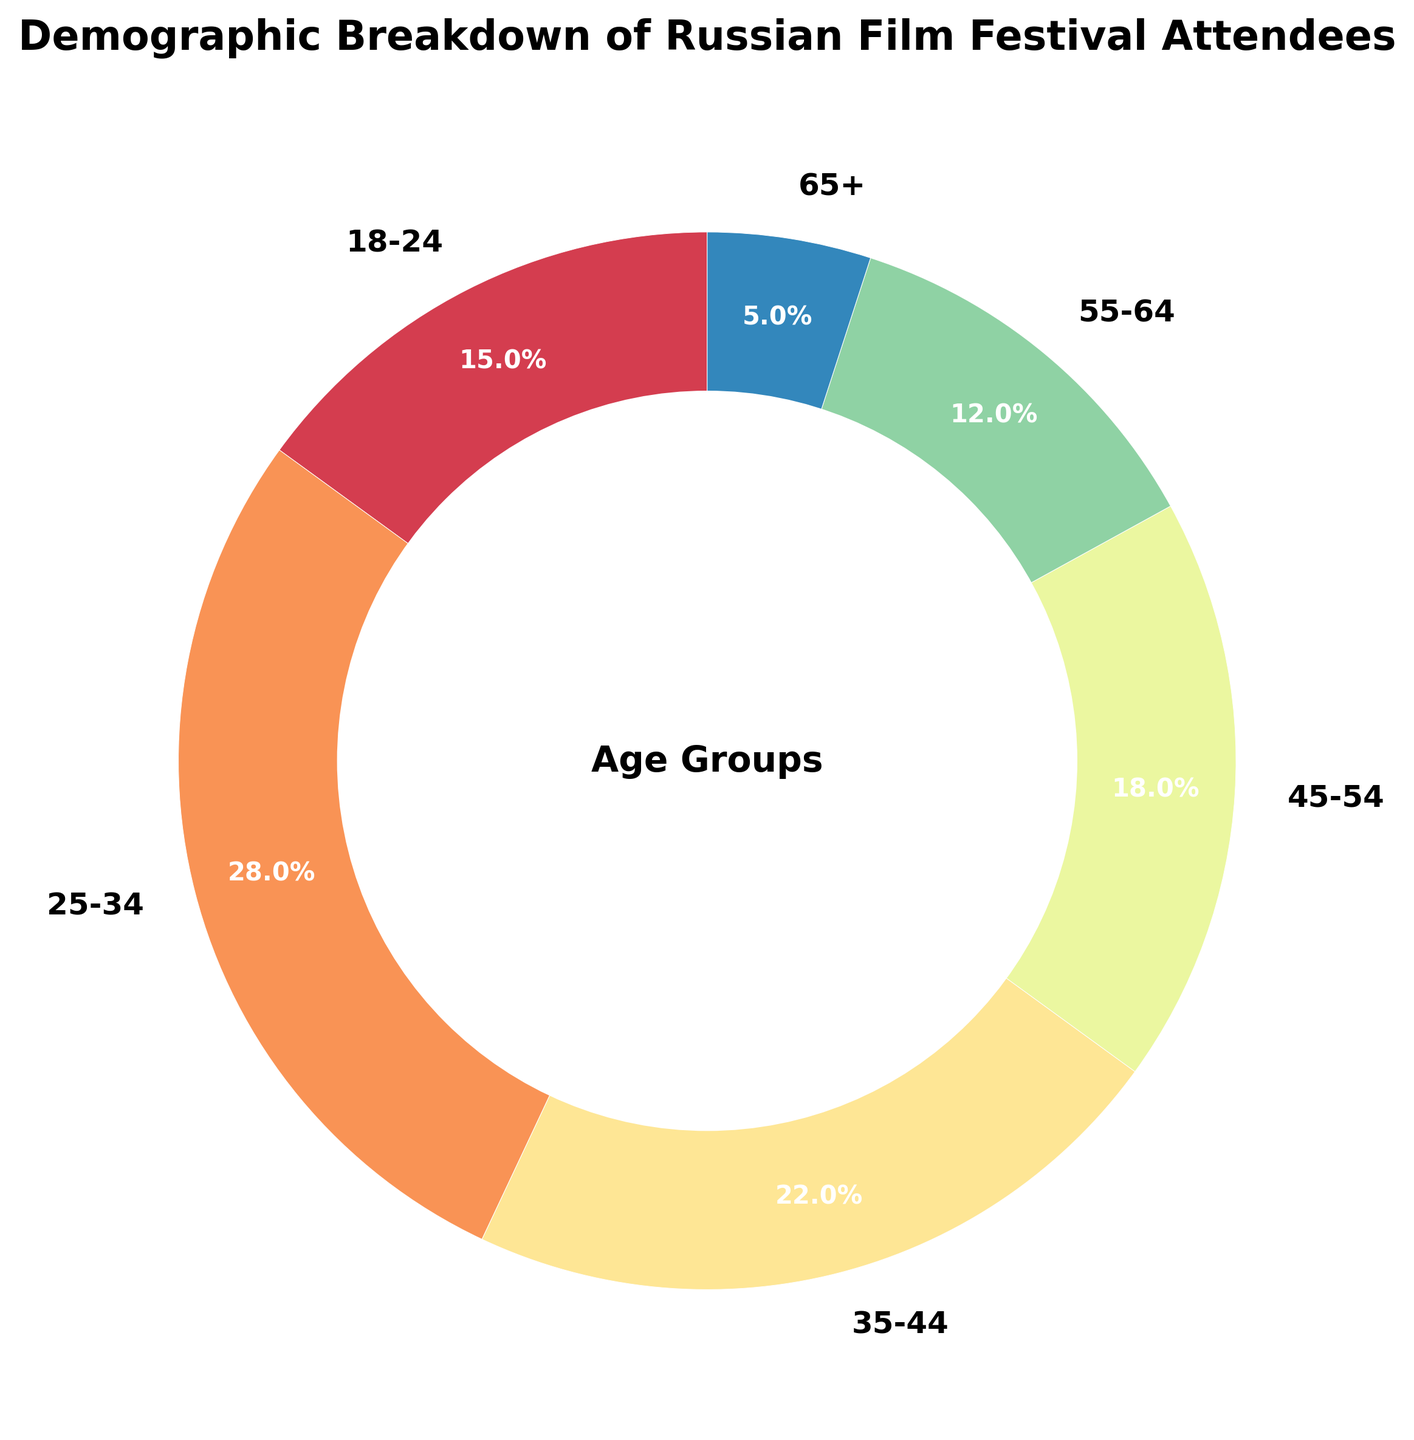What is the most represented age group at the festival? The figure shows that the age group 25-34 has the highest percentage at 28%, making it the most represented group.
Answer: 25-34 Which age group has the smallest percentage of attendees? The figure indicates that the age group 65+ has the smallest percentage at 5%.
Answer: 65+ What is the combined percentage of attendees aged 45-54 and 55-64? First, find the percentages for the 45-54 age group (18%) and the 55-64 age group (12%). Summing these percentages gives 18% + 12% = 30%.
Answer: 30% By how much does the percentage of attendees aged 25-34 exceed that of the 18-24 age group? The percentage for the age group 25-34 is 28%, and for the age group 18-24, it is 15%. To find the difference, subtract 15% from 28%: 28% - 15% = 13%.
Answer: 13% Which two age groups together make up less than 20% of the attendees? From the figure, adding the percentages for the age groups 55-64 (12%) and 65+ (5%), we get 12% + 5% = 17%. This is less than 20%.
Answer: 55-64 and 65+ What is the average percentage of attendees for all age groups? First, sum the percentages of all age groups: 15% + 28% + 22% + 18% + 12% + 5% = 100%. There are 6 age groups, so the average is 100% / 6 = 16.67%.
Answer: 16.67% If you randomly pick one attendee, what is the probability that they are from the 35-44 age group? The percentage of the 35-44 age group is 22%, which represents the probability that a randomly picked attendee is from this age group.
Answer: 22% How does the percentage of attendees aged 35-44 compare to those aged 45-54? The age group 35-44 has a percentage of 22%, while the age group 45-54 has 18%. Hence, the 35-44 age group exceeds the 45-54 age group by 4%.
Answer: 4% Which age group has more attendees, 18-24 or 55-64? The figure shows that the 18-24 age group has a percentage of 15%, whereas the 55-64 age group has 12%. Therefore, the 18-24 age group has a higher percentage of attendees.
Answer: 18-24 